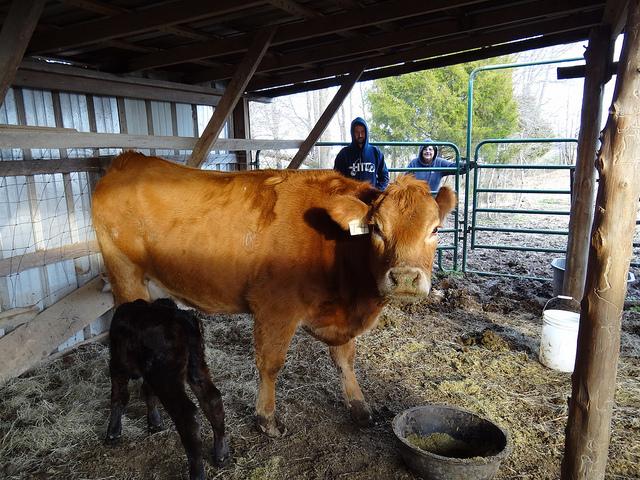What is the calf doing?
Answer briefly. Eating. How many humans are in the picture?
Write a very short answer. 2. What color is the calf?
Quick response, please. Brown. 